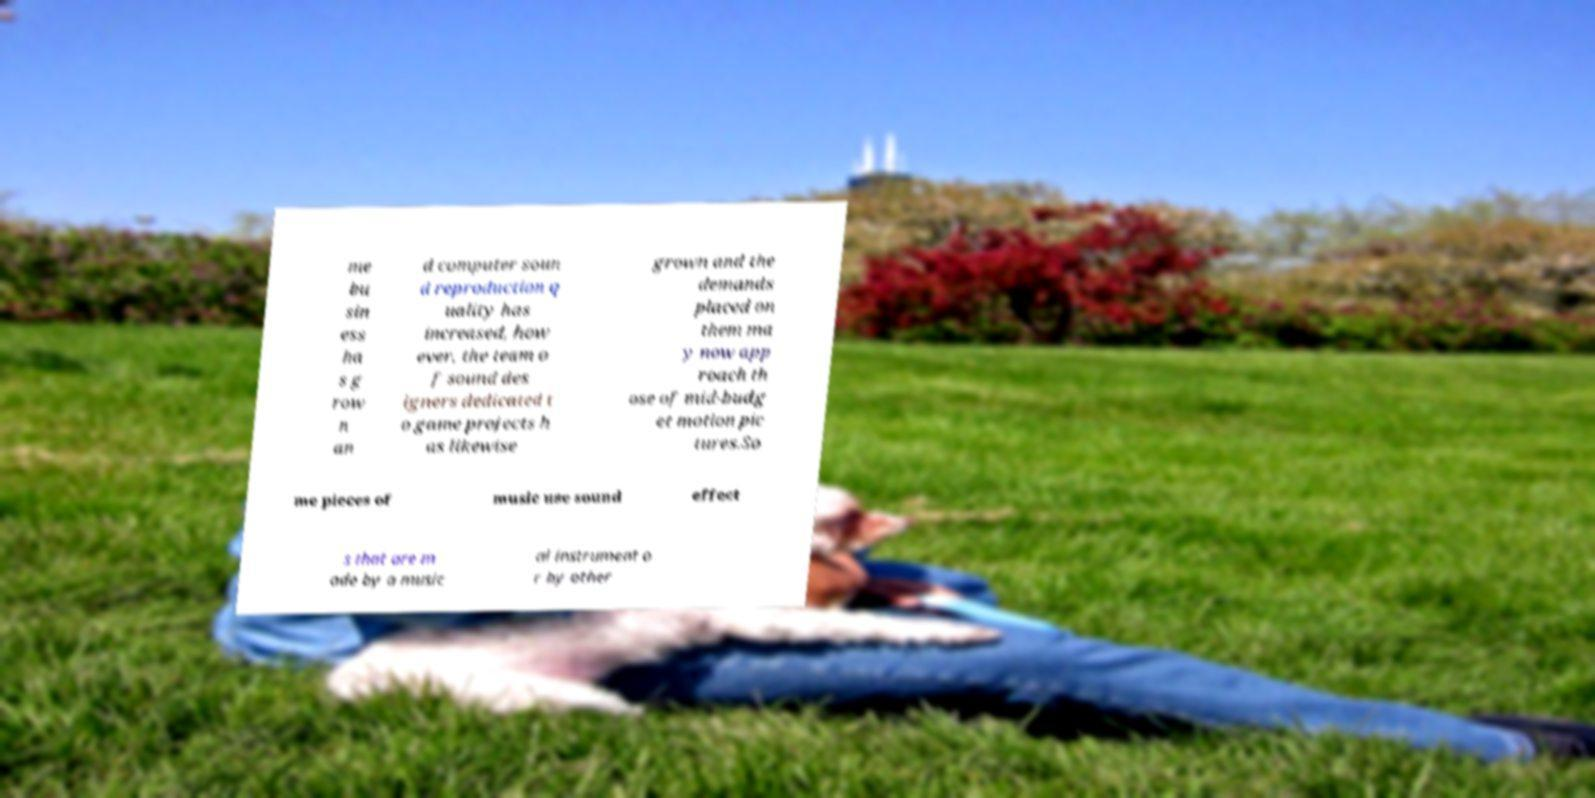For documentation purposes, I need the text within this image transcribed. Could you provide that? me bu sin ess ha s g row n an d computer soun d reproduction q uality has increased, how ever, the team o f sound des igners dedicated t o game projects h as likewise grown and the demands placed on them ma y now app roach th ose of mid-budg et motion pic tures.So me pieces of music use sound effect s that are m ade by a music al instrument o r by other 